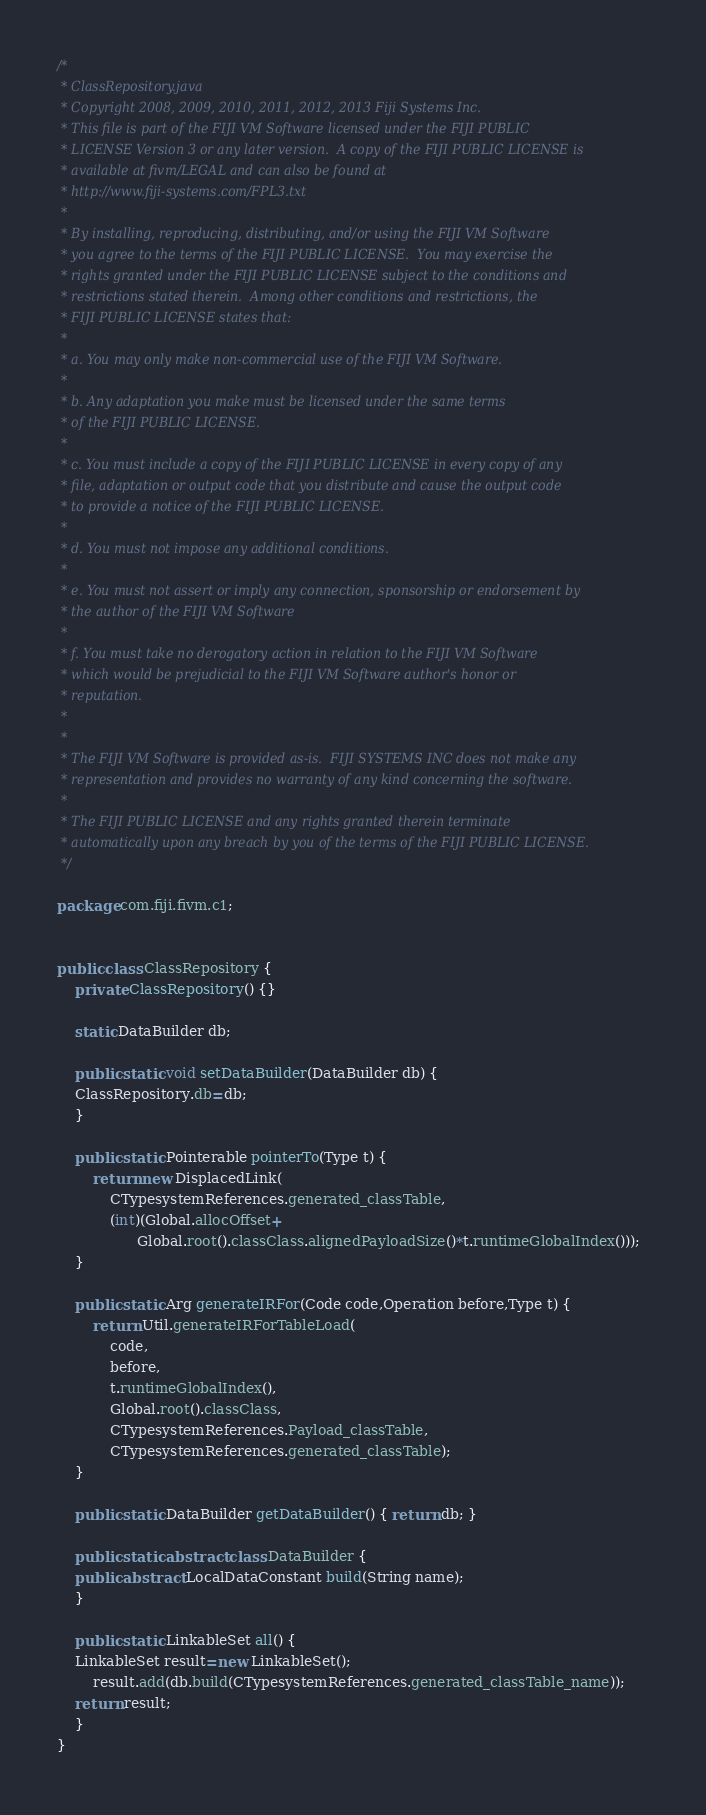Convert code to text. <code><loc_0><loc_0><loc_500><loc_500><_Java_>/*
 * ClassRepository.java
 * Copyright 2008, 2009, 2010, 2011, 2012, 2013 Fiji Systems Inc.
 * This file is part of the FIJI VM Software licensed under the FIJI PUBLIC
 * LICENSE Version 3 or any later version.  A copy of the FIJI PUBLIC LICENSE is
 * available at fivm/LEGAL and can also be found at
 * http://www.fiji-systems.com/FPL3.txt
 * 
 * By installing, reproducing, distributing, and/or using the FIJI VM Software
 * you agree to the terms of the FIJI PUBLIC LICENSE.  You may exercise the
 * rights granted under the FIJI PUBLIC LICENSE subject to the conditions and
 * restrictions stated therein.  Among other conditions and restrictions, the
 * FIJI PUBLIC LICENSE states that:
 * 
 * a. You may only make non-commercial use of the FIJI VM Software.
 * 
 * b. Any adaptation you make must be licensed under the same terms 
 * of the FIJI PUBLIC LICENSE.
 * 
 * c. You must include a copy of the FIJI PUBLIC LICENSE in every copy of any
 * file, adaptation or output code that you distribute and cause the output code
 * to provide a notice of the FIJI PUBLIC LICENSE. 
 * 
 * d. You must not impose any additional conditions.
 * 
 * e. You must not assert or imply any connection, sponsorship or endorsement by
 * the author of the FIJI VM Software
 * 
 * f. You must take no derogatory action in relation to the FIJI VM Software
 * which would be prejudicial to the FIJI VM Software author's honor or
 * reputation.
 * 
 * 
 * The FIJI VM Software is provided as-is.  FIJI SYSTEMS INC does not make any
 * representation and provides no warranty of any kind concerning the software.
 * 
 * The FIJI PUBLIC LICENSE and any rights granted therein terminate
 * automatically upon any breach by you of the terms of the FIJI PUBLIC LICENSE.
 */

package com.fiji.fivm.c1;


public class ClassRepository {
    private ClassRepository() {}
    
    static DataBuilder db;
    
    public static void setDataBuilder(DataBuilder db) {
	ClassRepository.db=db;
    }
    
    public static Pointerable pointerTo(Type t) {
        return new DisplacedLink(
            CTypesystemReferences.generated_classTable,
            (int)(Global.allocOffset+
                  Global.root().classClass.alignedPayloadSize()*t.runtimeGlobalIndex()));
    }
    
    public static Arg generateIRFor(Code code,Operation before,Type t) {
        return Util.generateIRForTableLoad(
            code,
            before,
            t.runtimeGlobalIndex(),
            Global.root().classClass,
            CTypesystemReferences.Payload_classTable,
            CTypesystemReferences.generated_classTable);
    }
    
    public static DataBuilder getDataBuilder() { return db; }
    
    public static abstract class DataBuilder {
	public abstract LocalDataConstant build(String name);
    }
    
    public static LinkableSet all() {
	LinkableSet result=new LinkableSet();
        result.add(db.build(CTypesystemReferences.generated_classTable_name));
	return result;
    }
}

</code> 